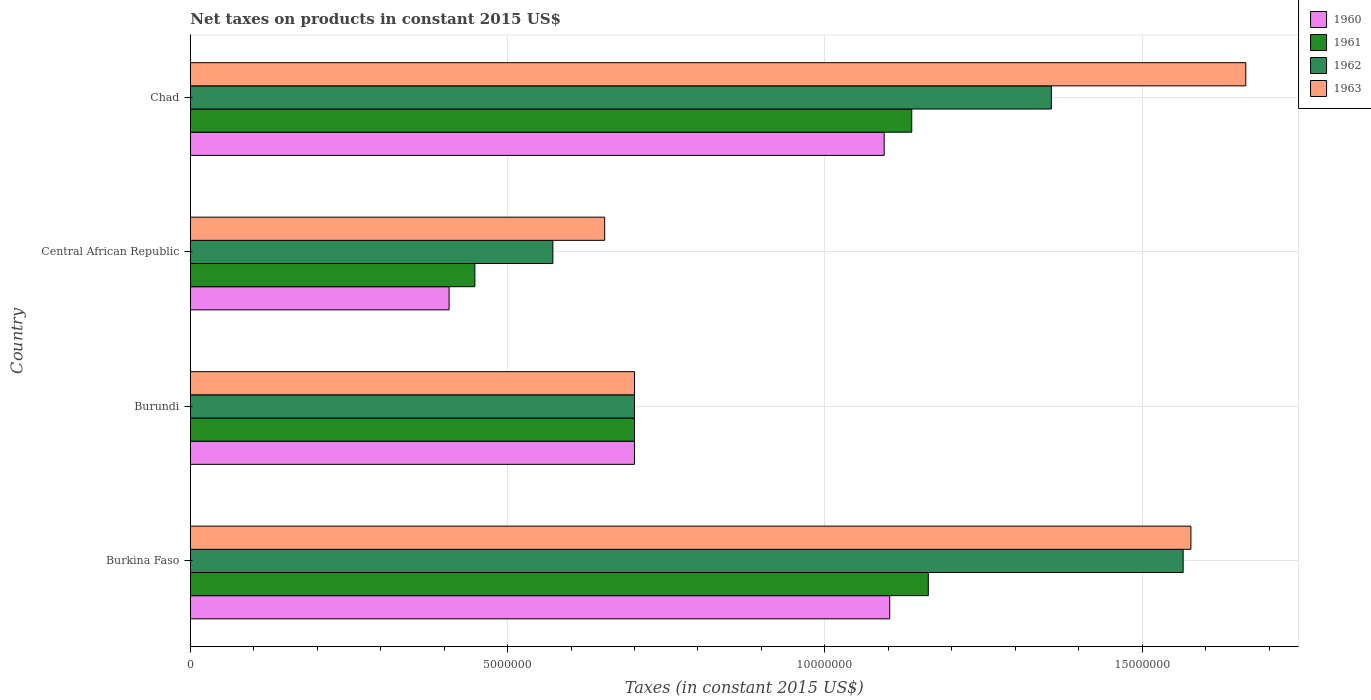How many groups of bars are there?
Offer a terse response. 4. Are the number of bars per tick equal to the number of legend labels?
Provide a succinct answer. Yes. How many bars are there on the 4th tick from the top?
Offer a very short reply. 4. How many bars are there on the 4th tick from the bottom?
Your response must be concise. 4. What is the label of the 4th group of bars from the top?
Keep it short and to the point. Burkina Faso. In how many cases, is the number of bars for a given country not equal to the number of legend labels?
Your answer should be compact. 0. What is the net taxes on products in 1960 in Burundi?
Provide a short and direct response. 7.00e+06. Across all countries, what is the maximum net taxes on products in 1962?
Provide a short and direct response. 1.56e+07. Across all countries, what is the minimum net taxes on products in 1960?
Offer a very short reply. 4.08e+06. In which country was the net taxes on products in 1962 maximum?
Give a very brief answer. Burkina Faso. In which country was the net taxes on products in 1960 minimum?
Provide a succinct answer. Central African Republic. What is the total net taxes on products in 1960 in the graph?
Your response must be concise. 3.30e+07. What is the difference between the net taxes on products in 1960 in Burkina Faso and that in Chad?
Your answer should be very brief. 8.71e+04. What is the difference between the net taxes on products in 1962 in Burkina Faso and the net taxes on products in 1963 in Central African Republic?
Your answer should be very brief. 9.12e+06. What is the average net taxes on products in 1961 per country?
Make the answer very short. 8.62e+06. What is the ratio of the net taxes on products in 1961 in Burkina Faso to that in Burundi?
Provide a short and direct response. 1.66. Is the net taxes on products in 1962 in Burundi less than that in Chad?
Offer a terse response. Yes. Is the difference between the net taxes on products in 1960 in Central African Republic and Chad greater than the difference between the net taxes on products in 1962 in Central African Republic and Chad?
Your answer should be compact. Yes. What is the difference between the highest and the second highest net taxes on products in 1963?
Offer a terse response. 8.65e+05. What is the difference between the highest and the lowest net taxes on products in 1961?
Your answer should be compact. 7.15e+06. In how many countries, is the net taxes on products in 1961 greater than the average net taxes on products in 1961 taken over all countries?
Provide a short and direct response. 2. Is the sum of the net taxes on products in 1961 in Burkina Faso and Chad greater than the maximum net taxes on products in 1960 across all countries?
Make the answer very short. Yes. How many bars are there?
Your answer should be compact. 16. How many countries are there in the graph?
Your answer should be very brief. 4. Are the values on the major ticks of X-axis written in scientific E-notation?
Offer a very short reply. No. Does the graph contain any zero values?
Give a very brief answer. No. Does the graph contain grids?
Ensure brevity in your answer.  Yes. Where does the legend appear in the graph?
Ensure brevity in your answer.  Top right. How many legend labels are there?
Your answer should be compact. 4. What is the title of the graph?
Ensure brevity in your answer.  Net taxes on products in constant 2015 US$. Does "2015" appear as one of the legend labels in the graph?
Provide a succinct answer. No. What is the label or title of the X-axis?
Keep it short and to the point. Taxes (in constant 2015 US$). What is the label or title of the Y-axis?
Keep it short and to the point. Country. What is the Taxes (in constant 2015 US$) in 1960 in Burkina Faso?
Make the answer very short. 1.10e+07. What is the Taxes (in constant 2015 US$) of 1961 in Burkina Faso?
Give a very brief answer. 1.16e+07. What is the Taxes (in constant 2015 US$) of 1962 in Burkina Faso?
Provide a short and direct response. 1.56e+07. What is the Taxes (in constant 2015 US$) in 1963 in Burkina Faso?
Offer a terse response. 1.58e+07. What is the Taxes (in constant 2015 US$) in 1960 in Burundi?
Give a very brief answer. 7.00e+06. What is the Taxes (in constant 2015 US$) of 1962 in Burundi?
Provide a succinct answer. 7.00e+06. What is the Taxes (in constant 2015 US$) in 1963 in Burundi?
Ensure brevity in your answer.  7.00e+06. What is the Taxes (in constant 2015 US$) of 1960 in Central African Republic?
Provide a short and direct response. 4.08e+06. What is the Taxes (in constant 2015 US$) of 1961 in Central African Republic?
Your response must be concise. 4.49e+06. What is the Taxes (in constant 2015 US$) in 1962 in Central African Republic?
Provide a short and direct response. 5.71e+06. What is the Taxes (in constant 2015 US$) in 1963 in Central African Republic?
Your answer should be very brief. 6.53e+06. What is the Taxes (in constant 2015 US$) of 1960 in Chad?
Give a very brief answer. 1.09e+07. What is the Taxes (in constant 2015 US$) of 1961 in Chad?
Provide a short and direct response. 1.14e+07. What is the Taxes (in constant 2015 US$) in 1962 in Chad?
Offer a very short reply. 1.36e+07. What is the Taxes (in constant 2015 US$) in 1963 in Chad?
Provide a succinct answer. 1.66e+07. Across all countries, what is the maximum Taxes (in constant 2015 US$) in 1960?
Your answer should be very brief. 1.10e+07. Across all countries, what is the maximum Taxes (in constant 2015 US$) in 1961?
Keep it short and to the point. 1.16e+07. Across all countries, what is the maximum Taxes (in constant 2015 US$) in 1962?
Your answer should be very brief. 1.56e+07. Across all countries, what is the maximum Taxes (in constant 2015 US$) in 1963?
Provide a short and direct response. 1.66e+07. Across all countries, what is the minimum Taxes (in constant 2015 US$) of 1960?
Your answer should be compact. 4.08e+06. Across all countries, what is the minimum Taxes (in constant 2015 US$) in 1961?
Your answer should be very brief. 4.49e+06. Across all countries, what is the minimum Taxes (in constant 2015 US$) in 1962?
Give a very brief answer. 5.71e+06. Across all countries, what is the minimum Taxes (in constant 2015 US$) of 1963?
Your answer should be very brief. 6.53e+06. What is the total Taxes (in constant 2015 US$) in 1960 in the graph?
Your answer should be very brief. 3.30e+07. What is the total Taxes (in constant 2015 US$) in 1961 in the graph?
Ensure brevity in your answer.  3.45e+07. What is the total Taxes (in constant 2015 US$) of 1962 in the graph?
Your response must be concise. 4.19e+07. What is the total Taxes (in constant 2015 US$) of 1963 in the graph?
Your response must be concise. 4.59e+07. What is the difference between the Taxes (in constant 2015 US$) of 1960 in Burkina Faso and that in Burundi?
Offer a terse response. 4.02e+06. What is the difference between the Taxes (in constant 2015 US$) in 1961 in Burkina Faso and that in Burundi?
Keep it short and to the point. 4.63e+06. What is the difference between the Taxes (in constant 2015 US$) of 1962 in Burkina Faso and that in Burundi?
Your answer should be very brief. 8.65e+06. What is the difference between the Taxes (in constant 2015 US$) in 1963 in Burkina Faso and that in Burundi?
Give a very brief answer. 8.77e+06. What is the difference between the Taxes (in constant 2015 US$) in 1960 in Burkina Faso and that in Central African Republic?
Offer a very short reply. 6.94e+06. What is the difference between the Taxes (in constant 2015 US$) in 1961 in Burkina Faso and that in Central African Republic?
Give a very brief answer. 7.15e+06. What is the difference between the Taxes (in constant 2015 US$) of 1962 in Burkina Faso and that in Central African Republic?
Your answer should be compact. 9.93e+06. What is the difference between the Taxes (in constant 2015 US$) of 1963 in Burkina Faso and that in Central African Republic?
Keep it short and to the point. 9.24e+06. What is the difference between the Taxes (in constant 2015 US$) of 1960 in Burkina Faso and that in Chad?
Give a very brief answer. 8.71e+04. What is the difference between the Taxes (in constant 2015 US$) in 1961 in Burkina Faso and that in Chad?
Your answer should be compact. 2.61e+05. What is the difference between the Taxes (in constant 2015 US$) of 1962 in Burkina Faso and that in Chad?
Your answer should be very brief. 2.08e+06. What is the difference between the Taxes (in constant 2015 US$) in 1963 in Burkina Faso and that in Chad?
Keep it short and to the point. -8.65e+05. What is the difference between the Taxes (in constant 2015 US$) of 1960 in Burundi and that in Central African Republic?
Give a very brief answer. 2.92e+06. What is the difference between the Taxes (in constant 2015 US$) in 1961 in Burundi and that in Central African Republic?
Your answer should be compact. 2.51e+06. What is the difference between the Taxes (in constant 2015 US$) of 1962 in Burundi and that in Central African Republic?
Provide a succinct answer. 1.29e+06. What is the difference between the Taxes (in constant 2015 US$) in 1963 in Burundi and that in Central African Republic?
Make the answer very short. 4.70e+05. What is the difference between the Taxes (in constant 2015 US$) in 1960 in Burundi and that in Chad?
Keep it short and to the point. -3.94e+06. What is the difference between the Taxes (in constant 2015 US$) in 1961 in Burundi and that in Chad?
Offer a very short reply. -4.37e+06. What is the difference between the Taxes (in constant 2015 US$) of 1962 in Burundi and that in Chad?
Ensure brevity in your answer.  -6.57e+06. What is the difference between the Taxes (in constant 2015 US$) in 1963 in Burundi and that in Chad?
Offer a terse response. -9.63e+06. What is the difference between the Taxes (in constant 2015 US$) of 1960 in Central African Republic and that in Chad?
Provide a short and direct response. -6.86e+06. What is the difference between the Taxes (in constant 2015 US$) of 1961 in Central African Republic and that in Chad?
Provide a succinct answer. -6.88e+06. What is the difference between the Taxes (in constant 2015 US$) in 1962 in Central African Republic and that in Chad?
Keep it short and to the point. -7.86e+06. What is the difference between the Taxes (in constant 2015 US$) in 1963 in Central African Republic and that in Chad?
Your answer should be compact. -1.01e+07. What is the difference between the Taxes (in constant 2015 US$) of 1960 in Burkina Faso and the Taxes (in constant 2015 US$) of 1961 in Burundi?
Provide a short and direct response. 4.02e+06. What is the difference between the Taxes (in constant 2015 US$) of 1960 in Burkina Faso and the Taxes (in constant 2015 US$) of 1962 in Burundi?
Offer a terse response. 4.02e+06. What is the difference between the Taxes (in constant 2015 US$) in 1960 in Burkina Faso and the Taxes (in constant 2015 US$) in 1963 in Burundi?
Your answer should be very brief. 4.02e+06. What is the difference between the Taxes (in constant 2015 US$) in 1961 in Burkina Faso and the Taxes (in constant 2015 US$) in 1962 in Burundi?
Offer a terse response. 4.63e+06. What is the difference between the Taxes (in constant 2015 US$) in 1961 in Burkina Faso and the Taxes (in constant 2015 US$) in 1963 in Burundi?
Make the answer very short. 4.63e+06. What is the difference between the Taxes (in constant 2015 US$) of 1962 in Burkina Faso and the Taxes (in constant 2015 US$) of 1963 in Burundi?
Your answer should be very brief. 8.65e+06. What is the difference between the Taxes (in constant 2015 US$) of 1960 in Burkina Faso and the Taxes (in constant 2015 US$) of 1961 in Central African Republic?
Provide a short and direct response. 6.54e+06. What is the difference between the Taxes (in constant 2015 US$) in 1960 in Burkina Faso and the Taxes (in constant 2015 US$) in 1962 in Central African Republic?
Ensure brevity in your answer.  5.31e+06. What is the difference between the Taxes (in constant 2015 US$) in 1960 in Burkina Faso and the Taxes (in constant 2015 US$) in 1963 in Central African Republic?
Offer a terse response. 4.49e+06. What is the difference between the Taxes (in constant 2015 US$) in 1961 in Burkina Faso and the Taxes (in constant 2015 US$) in 1962 in Central African Republic?
Provide a short and direct response. 5.92e+06. What is the difference between the Taxes (in constant 2015 US$) in 1961 in Burkina Faso and the Taxes (in constant 2015 US$) in 1963 in Central African Republic?
Give a very brief answer. 5.10e+06. What is the difference between the Taxes (in constant 2015 US$) in 1962 in Burkina Faso and the Taxes (in constant 2015 US$) in 1963 in Central African Republic?
Your response must be concise. 9.12e+06. What is the difference between the Taxes (in constant 2015 US$) of 1960 in Burkina Faso and the Taxes (in constant 2015 US$) of 1961 in Chad?
Offer a terse response. -3.47e+05. What is the difference between the Taxes (in constant 2015 US$) of 1960 in Burkina Faso and the Taxes (in constant 2015 US$) of 1962 in Chad?
Keep it short and to the point. -2.55e+06. What is the difference between the Taxes (in constant 2015 US$) in 1960 in Burkina Faso and the Taxes (in constant 2015 US$) in 1963 in Chad?
Offer a very short reply. -5.61e+06. What is the difference between the Taxes (in constant 2015 US$) of 1961 in Burkina Faso and the Taxes (in constant 2015 US$) of 1962 in Chad?
Make the answer very short. -1.94e+06. What is the difference between the Taxes (in constant 2015 US$) of 1961 in Burkina Faso and the Taxes (in constant 2015 US$) of 1963 in Chad?
Your response must be concise. -5.00e+06. What is the difference between the Taxes (in constant 2015 US$) of 1962 in Burkina Faso and the Taxes (in constant 2015 US$) of 1963 in Chad?
Keep it short and to the point. -9.87e+05. What is the difference between the Taxes (in constant 2015 US$) in 1960 in Burundi and the Taxes (in constant 2015 US$) in 1961 in Central African Republic?
Provide a short and direct response. 2.51e+06. What is the difference between the Taxes (in constant 2015 US$) in 1960 in Burundi and the Taxes (in constant 2015 US$) in 1962 in Central African Republic?
Offer a terse response. 1.29e+06. What is the difference between the Taxes (in constant 2015 US$) of 1960 in Burundi and the Taxes (in constant 2015 US$) of 1963 in Central African Republic?
Keep it short and to the point. 4.70e+05. What is the difference between the Taxes (in constant 2015 US$) of 1961 in Burundi and the Taxes (in constant 2015 US$) of 1962 in Central African Republic?
Provide a succinct answer. 1.29e+06. What is the difference between the Taxes (in constant 2015 US$) of 1961 in Burundi and the Taxes (in constant 2015 US$) of 1963 in Central African Republic?
Provide a short and direct response. 4.70e+05. What is the difference between the Taxes (in constant 2015 US$) of 1962 in Burundi and the Taxes (in constant 2015 US$) of 1963 in Central African Republic?
Offer a terse response. 4.70e+05. What is the difference between the Taxes (in constant 2015 US$) in 1960 in Burundi and the Taxes (in constant 2015 US$) in 1961 in Chad?
Your answer should be compact. -4.37e+06. What is the difference between the Taxes (in constant 2015 US$) in 1960 in Burundi and the Taxes (in constant 2015 US$) in 1962 in Chad?
Your answer should be compact. -6.57e+06. What is the difference between the Taxes (in constant 2015 US$) in 1960 in Burundi and the Taxes (in constant 2015 US$) in 1963 in Chad?
Ensure brevity in your answer.  -9.63e+06. What is the difference between the Taxes (in constant 2015 US$) of 1961 in Burundi and the Taxes (in constant 2015 US$) of 1962 in Chad?
Keep it short and to the point. -6.57e+06. What is the difference between the Taxes (in constant 2015 US$) in 1961 in Burundi and the Taxes (in constant 2015 US$) in 1963 in Chad?
Keep it short and to the point. -9.63e+06. What is the difference between the Taxes (in constant 2015 US$) in 1962 in Burundi and the Taxes (in constant 2015 US$) in 1963 in Chad?
Provide a succinct answer. -9.63e+06. What is the difference between the Taxes (in constant 2015 US$) of 1960 in Central African Republic and the Taxes (in constant 2015 US$) of 1961 in Chad?
Your answer should be very brief. -7.29e+06. What is the difference between the Taxes (in constant 2015 US$) of 1960 in Central African Republic and the Taxes (in constant 2015 US$) of 1962 in Chad?
Give a very brief answer. -9.49e+06. What is the difference between the Taxes (in constant 2015 US$) in 1960 in Central African Republic and the Taxes (in constant 2015 US$) in 1963 in Chad?
Ensure brevity in your answer.  -1.26e+07. What is the difference between the Taxes (in constant 2015 US$) of 1961 in Central African Republic and the Taxes (in constant 2015 US$) of 1962 in Chad?
Keep it short and to the point. -9.08e+06. What is the difference between the Taxes (in constant 2015 US$) in 1961 in Central African Republic and the Taxes (in constant 2015 US$) in 1963 in Chad?
Provide a short and direct response. -1.21e+07. What is the difference between the Taxes (in constant 2015 US$) of 1962 in Central African Republic and the Taxes (in constant 2015 US$) of 1963 in Chad?
Give a very brief answer. -1.09e+07. What is the average Taxes (in constant 2015 US$) of 1960 per country?
Provide a short and direct response. 8.26e+06. What is the average Taxes (in constant 2015 US$) in 1961 per country?
Offer a terse response. 8.62e+06. What is the average Taxes (in constant 2015 US$) in 1962 per country?
Your answer should be very brief. 1.05e+07. What is the average Taxes (in constant 2015 US$) in 1963 per country?
Your answer should be compact. 1.15e+07. What is the difference between the Taxes (in constant 2015 US$) in 1960 and Taxes (in constant 2015 US$) in 1961 in Burkina Faso?
Ensure brevity in your answer.  -6.08e+05. What is the difference between the Taxes (in constant 2015 US$) in 1960 and Taxes (in constant 2015 US$) in 1962 in Burkina Faso?
Make the answer very short. -4.62e+06. What is the difference between the Taxes (in constant 2015 US$) in 1960 and Taxes (in constant 2015 US$) in 1963 in Burkina Faso?
Provide a short and direct response. -4.75e+06. What is the difference between the Taxes (in constant 2015 US$) of 1961 and Taxes (in constant 2015 US$) of 1962 in Burkina Faso?
Your answer should be very brief. -4.02e+06. What is the difference between the Taxes (in constant 2015 US$) in 1961 and Taxes (in constant 2015 US$) in 1963 in Burkina Faso?
Offer a very short reply. -4.14e+06. What is the difference between the Taxes (in constant 2015 US$) in 1962 and Taxes (in constant 2015 US$) in 1963 in Burkina Faso?
Your answer should be very brief. -1.22e+05. What is the difference between the Taxes (in constant 2015 US$) in 1960 and Taxes (in constant 2015 US$) in 1961 in Burundi?
Ensure brevity in your answer.  0. What is the difference between the Taxes (in constant 2015 US$) in 1961 and Taxes (in constant 2015 US$) in 1963 in Burundi?
Your answer should be compact. 0. What is the difference between the Taxes (in constant 2015 US$) of 1960 and Taxes (in constant 2015 US$) of 1961 in Central African Republic?
Offer a terse response. -4.07e+05. What is the difference between the Taxes (in constant 2015 US$) in 1960 and Taxes (in constant 2015 US$) in 1962 in Central African Republic?
Give a very brief answer. -1.64e+06. What is the difference between the Taxes (in constant 2015 US$) of 1960 and Taxes (in constant 2015 US$) of 1963 in Central African Republic?
Provide a short and direct response. -2.45e+06. What is the difference between the Taxes (in constant 2015 US$) of 1961 and Taxes (in constant 2015 US$) of 1962 in Central African Republic?
Ensure brevity in your answer.  -1.23e+06. What is the difference between the Taxes (in constant 2015 US$) in 1961 and Taxes (in constant 2015 US$) in 1963 in Central African Republic?
Provide a succinct answer. -2.05e+06. What is the difference between the Taxes (in constant 2015 US$) of 1962 and Taxes (in constant 2015 US$) of 1963 in Central African Republic?
Offer a very short reply. -8.16e+05. What is the difference between the Taxes (in constant 2015 US$) in 1960 and Taxes (in constant 2015 US$) in 1961 in Chad?
Offer a very short reply. -4.34e+05. What is the difference between the Taxes (in constant 2015 US$) of 1960 and Taxes (in constant 2015 US$) of 1962 in Chad?
Your response must be concise. -2.63e+06. What is the difference between the Taxes (in constant 2015 US$) in 1960 and Taxes (in constant 2015 US$) in 1963 in Chad?
Your answer should be compact. -5.70e+06. What is the difference between the Taxes (in constant 2015 US$) in 1961 and Taxes (in constant 2015 US$) in 1962 in Chad?
Provide a short and direct response. -2.20e+06. What is the difference between the Taxes (in constant 2015 US$) of 1961 and Taxes (in constant 2015 US$) of 1963 in Chad?
Keep it short and to the point. -5.26e+06. What is the difference between the Taxes (in constant 2015 US$) of 1962 and Taxes (in constant 2015 US$) of 1963 in Chad?
Your answer should be compact. -3.06e+06. What is the ratio of the Taxes (in constant 2015 US$) in 1960 in Burkina Faso to that in Burundi?
Provide a short and direct response. 1.57. What is the ratio of the Taxes (in constant 2015 US$) of 1961 in Burkina Faso to that in Burundi?
Provide a short and direct response. 1.66. What is the ratio of the Taxes (in constant 2015 US$) in 1962 in Burkina Faso to that in Burundi?
Your response must be concise. 2.24. What is the ratio of the Taxes (in constant 2015 US$) in 1963 in Burkina Faso to that in Burundi?
Give a very brief answer. 2.25. What is the ratio of the Taxes (in constant 2015 US$) in 1960 in Burkina Faso to that in Central African Republic?
Your response must be concise. 2.7. What is the ratio of the Taxes (in constant 2015 US$) in 1961 in Burkina Faso to that in Central African Republic?
Keep it short and to the point. 2.59. What is the ratio of the Taxes (in constant 2015 US$) in 1962 in Burkina Faso to that in Central African Republic?
Keep it short and to the point. 2.74. What is the ratio of the Taxes (in constant 2015 US$) of 1963 in Burkina Faso to that in Central African Republic?
Your answer should be compact. 2.41. What is the ratio of the Taxes (in constant 2015 US$) of 1960 in Burkina Faso to that in Chad?
Your response must be concise. 1.01. What is the ratio of the Taxes (in constant 2015 US$) of 1961 in Burkina Faso to that in Chad?
Ensure brevity in your answer.  1.02. What is the ratio of the Taxes (in constant 2015 US$) in 1962 in Burkina Faso to that in Chad?
Your answer should be compact. 1.15. What is the ratio of the Taxes (in constant 2015 US$) in 1963 in Burkina Faso to that in Chad?
Keep it short and to the point. 0.95. What is the ratio of the Taxes (in constant 2015 US$) in 1960 in Burundi to that in Central African Republic?
Ensure brevity in your answer.  1.72. What is the ratio of the Taxes (in constant 2015 US$) of 1961 in Burundi to that in Central African Republic?
Your response must be concise. 1.56. What is the ratio of the Taxes (in constant 2015 US$) in 1962 in Burundi to that in Central African Republic?
Offer a very short reply. 1.23. What is the ratio of the Taxes (in constant 2015 US$) of 1963 in Burundi to that in Central African Republic?
Offer a very short reply. 1.07. What is the ratio of the Taxes (in constant 2015 US$) of 1960 in Burundi to that in Chad?
Provide a succinct answer. 0.64. What is the ratio of the Taxes (in constant 2015 US$) in 1961 in Burundi to that in Chad?
Offer a very short reply. 0.62. What is the ratio of the Taxes (in constant 2015 US$) in 1962 in Burundi to that in Chad?
Ensure brevity in your answer.  0.52. What is the ratio of the Taxes (in constant 2015 US$) in 1963 in Burundi to that in Chad?
Make the answer very short. 0.42. What is the ratio of the Taxes (in constant 2015 US$) of 1960 in Central African Republic to that in Chad?
Offer a very short reply. 0.37. What is the ratio of the Taxes (in constant 2015 US$) of 1961 in Central African Republic to that in Chad?
Provide a succinct answer. 0.39. What is the ratio of the Taxes (in constant 2015 US$) in 1962 in Central African Republic to that in Chad?
Your response must be concise. 0.42. What is the ratio of the Taxes (in constant 2015 US$) of 1963 in Central African Republic to that in Chad?
Offer a terse response. 0.39. What is the difference between the highest and the second highest Taxes (in constant 2015 US$) in 1960?
Make the answer very short. 8.71e+04. What is the difference between the highest and the second highest Taxes (in constant 2015 US$) of 1961?
Offer a terse response. 2.61e+05. What is the difference between the highest and the second highest Taxes (in constant 2015 US$) in 1962?
Offer a terse response. 2.08e+06. What is the difference between the highest and the second highest Taxes (in constant 2015 US$) in 1963?
Provide a succinct answer. 8.65e+05. What is the difference between the highest and the lowest Taxes (in constant 2015 US$) of 1960?
Provide a succinct answer. 6.94e+06. What is the difference between the highest and the lowest Taxes (in constant 2015 US$) of 1961?
Your answer should be compact. 7.15e+06. What is the difference between the highest and the lowest Taxes (in constant 2015 US$) in 1962?
Provide a short and direct response. 9.93e+06. What is the difference between the highest and the lowest Taxes (in constant 2015 US$) of 1963?
Ensure brevity in your answer.  1.01e+07. 